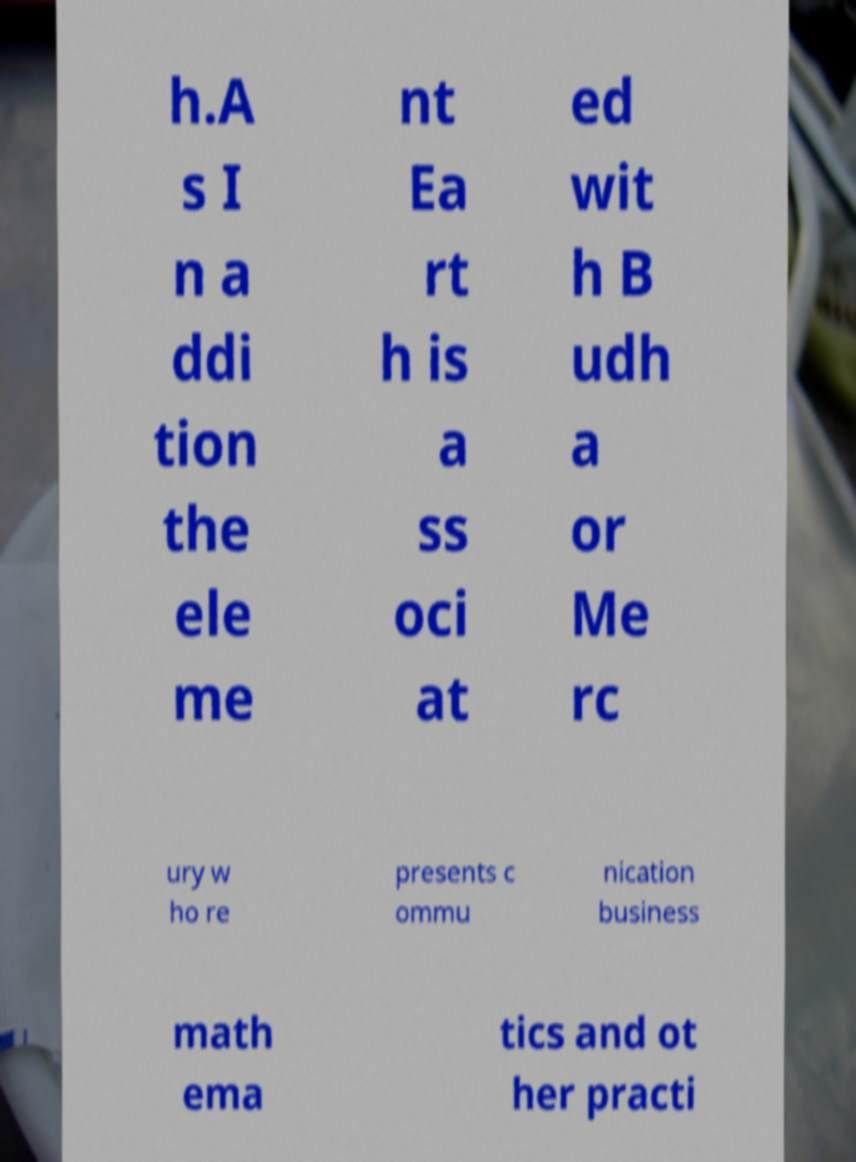Please identify and transcribe the text found in this image. h.A s I n a ddi tion the ele me nt Ea rt h is a ss oci at ed wit h B udh a or Me rc ury w ho re presents c ommu nication business math ema tics and ot her practi 